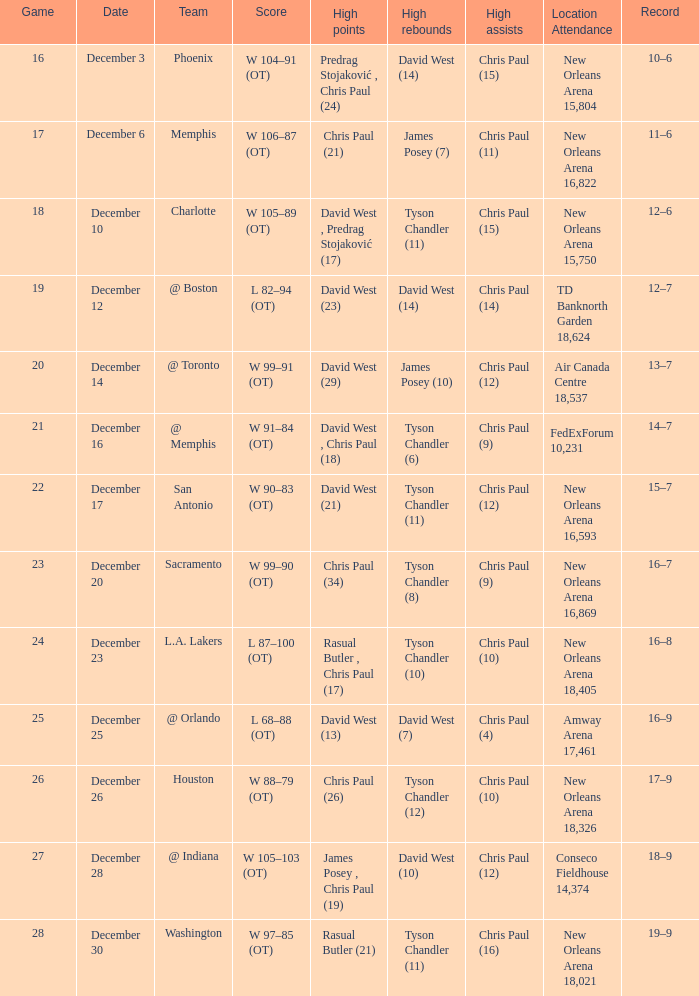What is the typical game, when date is "december 23"? 24.0. 